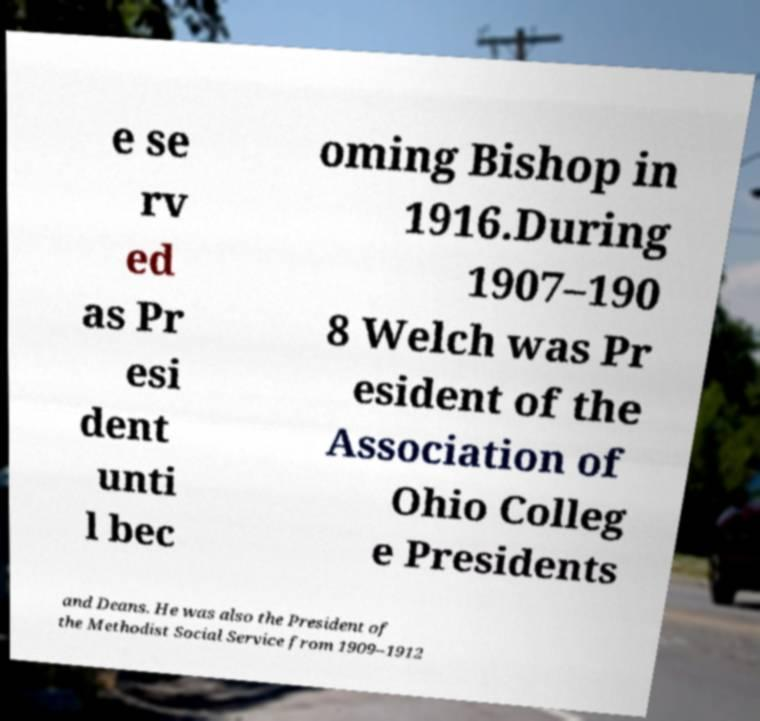There's text embedded in this image that I need extracted. Can you transcribe it verbatim? e se rv ed as Pr esi dent unti l bec oming Bishop in 1916.During 1907–190 8 Welch was Pr esident of the Association of Ohio Colleg e Presidents and Deans. He was also the President of the Methodist Social Service from 1909–1912 